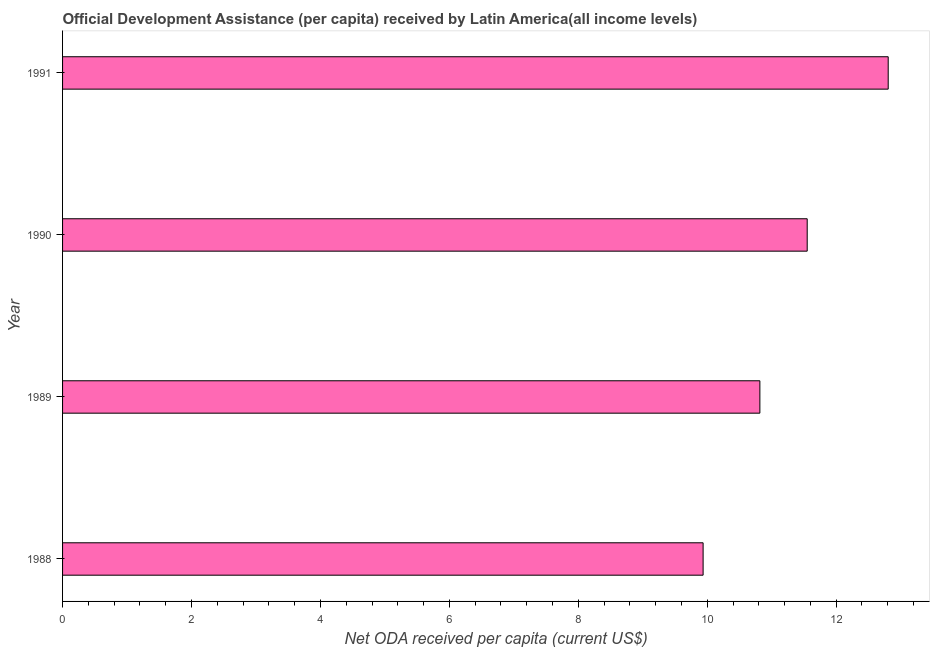Does the graph contain any zero values?
Give a very brief answer. No. What is the title of the graph?
Offer a terse response. Official Development Assistance (per capita) received by Latin America(all income levels). What is the label or title of the X-axis?
Provide a succinct answer. Net ODA received per capita (current US$). What is the label or title of the Y-axis?
Ensure brevity in your answer.  Year. What is the net oda received per capita in 1988?
Your response must be concise. 9.94. Across all years, what is the maximum net oda received per capita?
Give a very brief answer. 12.81. Across all years, what is the minimum net oda received per capita?
Your answer should be very brief. 9.94. In which year was the net oda received per capita maximum?
Ensure brevity in your answer.  1991. In which year was the net oda received per capita minimum?
Your answer should be compact. 1988. What is the sum of the net oda received per capita?
Make the answer very short. 45.11. What is the difference between the net oda received per capita in 1990 and 1991?
Give a very brief answer. -1.26. What is the average net oda received per capita per year?
Your answer should be compact. 11.28. What is the median net oda received per capita?
Give a very brief answer. 11.18. In how many years, is the net oda received per capita greater than 9.6 US$?
Your answer should be compact. 4. What is the ratio of the net oda received per capita in 1988 to that in 1991?
Give a very brief answer. 0.78. What is the difference between the highest and the second highest net oda received per capita?
Provide a succinct answer. 1.26. Is the sum of the net oda received per capita in 1989 and 1990 greater than the maximum net oda received per capita across all years?
Keep it short and to the point. Yes. What is the difference between the highest and the lowest net oda received per capita?
Make the answer very short. 2.87. Are all the bars in the graph horizontal?
Provide a succinct answer. Yes. How many years are there in the graph?
Your answer should be compact. 4. What is the difference between two consecutive major ticks on the X-axis?
Ensure brevity in your answer.  2. What is the Net ODA received per capita (current US$) of 1988?
Your answer should be compact. 9.94. What is the Net ODA received per capita (current US$) of 1989?
Keep it short and to the point. 10.82. What is the Net ODA received per capita (current US$) of 1990?
Offer a very short reply. 11.55. What is the Net ODA received per capita (current US$) of 1991?
Your response must be concise. 12.81. What is the difference between the Net ODA received per capita (current US$) in 1988 and 1989?
Your response must be concise. -0.88. What is the difference between the Net ODA received per capita (current US$) in 1988 and 1990?
Offer a very short reply. -1.61. What is the difference between the Net ODA received per capita (current US$) in 1988 and 1991?
Provide a short and direct response. -2.87. What is the difference between the Net ODA received per capita (current US$) in 1989 and 1990?
Provide a succinct answer. -0.73. What is the difference between the Net ODA received per capita (current US$) in 1989 and 1991?
Provide a succinct answer. -1.99. What is the difference between the Net ODA received per capita (current US$) in 1990 and 1991?
Make the answer very short. -1.26. What is the ratio of the Net ODA received per capita (current US$) in 1988 to that in 1989?
Provide a short and direct response. 0.92. What is the ratio of the Net ODA received per capita (current US$) in 1988 to that in 1990?
Offer a terse response. 0.86. What is the ratio of the Net ODA received per capita (current US$) in 1988 to that in 1991?
Your answer should be very brief. 0.78. What is the ratio of the Net ODA received per capita (current US$) in 1989 to that in 1990?
Your answer should be very brief. 0.94. What is the ratio of the Net ODA received per capita (current US$) in 1989 to that in 1991?
Make the answer very short. 0.84. What is the ratio of the Net ODA received per capita (current US$) in 1990 to that in 1991?
Offer a terse response. 0.9. 